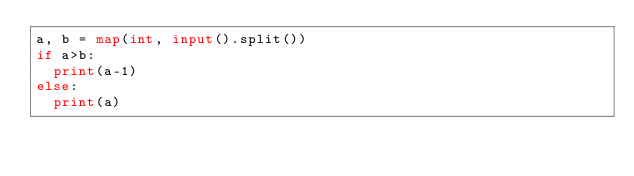Convert code to text. <code><loc_0><loc_0><loc_500><loc_500><_Python_>a, b = map(int, input().split())
if a>b:
	print(a-1)
else:
	print(a)</code> 